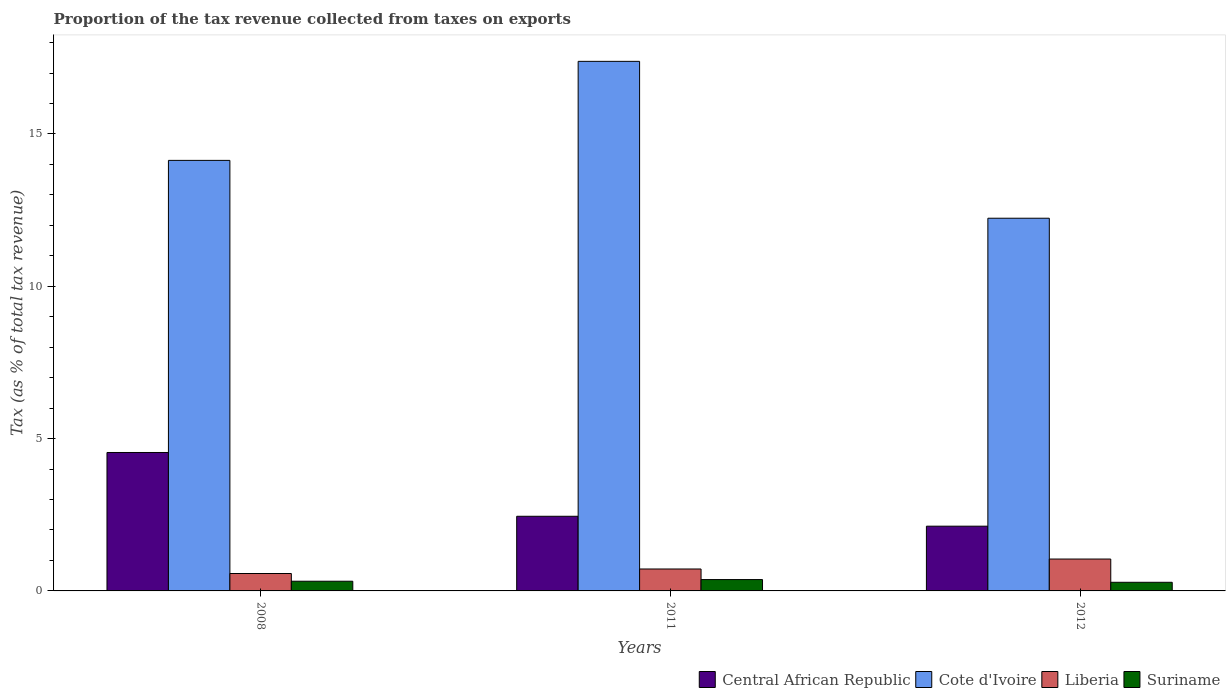How many different coloured bars are there?
Offer a very short reply. 4. How many groups of bars are there?
Your answer should be very brief. 3. How many bars are there on the 3rd tick from the right?
Offer a terse response. 4. What is the label of the 2nd group of bars from the left?
Your answer should be very brief. 2011. What is the proportion of the tax revenue collected in Central African Republic in 2012?
Offer a very short reply. 2.13. Across all years, what is the maximum proportion of the tax revenue collected in Cote d'Ivoire?
Offer a terse response. 17.38. Across all years, what is the minimum proportion of the tax revenue collected in Central African Republic?
Offer a terse response. 2.13. In which year was the proportion of the tax revenue collected in Central African Republic maximum?
Your answer should be compact. 2008. In which year was the proportion of the tax revenue collected in Central African Republic minimum?
Offer a very short reply. 2012. What is the total proportion of the tax revenue collected in Suriname in the graph?
Keep it short and to the point. 0.97. What is the difference between the proportion of the tax revenue collected in Central African Republic in 2011 and that in 2012?
Offer a terse response. 0.33. What is the difference between the proportion of the tax revenue collected in Suriname in 2008 and the proportion of the tax revenue collected in Liberia in 2012?
Ensure brevity in your answer.  -0.73. What is the average proportion of the tax revenue collected in Suriname per year?
Offer a very short reply. 0.32. In the year 2011, what is the difference between the proportion of the tax revenue collected in Liberia and proportion of the tax revenue collected in Central African Republic?
Offer a very short reply. -1.73. In how many years, is the proportion of the tax revenue collected in Liberia greater than 12 %?
Your answer should be very brief. 0. What is the ratio of the proportion of the tax revenue collected in Cote d'Ivoire in 2008 to that in 2011?
Keep it short and to the point. 0.81. Is the difference between the proportion of the tax revenue collected in Liberia in 2011 and 2012 greater than the difference between the proportion of the tax revenue collected in Central African Republic in 2011 and 2012?
Your response must be concise. No. What is the difference between the highest and the second highest proportion of the tax revenue collected in Central African Republic?
Give a very brief answer. 2.09. What is the difference between the highest and the lowest proportion of the tax revenue collected in Cote d'Ivoire?
Your answer should be compact. 5.15. In how many years, is the proportion of the tax revenue collected in Suriname greater than the average proportion of the tax revenue collected in Suriname taken over all years?
Make the answer very short. 1. Is it the case that in every year, the sum of the proportion of the tax revenue collected in Cote d'Ivoire and proportion of the tax revenue collected in Suriname is greater than the sum of proportion of the tax revenue collected in Central African Republic and proportion of the tax revenue collected in Liberia?
Your answer should be compact. Yes. What does the 3rd bar from the left in 2011 represents?
Provide a short and direct response. Liberia. What does the 1st bar from the right in 2011 represents?
Your answer should be compact. Suriname. Is it the case that in every year, the sum of the proportion of the tax revenue collected in Suriname and proportion of the tax revenue collected in Central African Republic is greater than the proportion of the tax revenue collected in Cote d'Ivoire?
Provide a succinct answer. No. How many bars are there?
Keep it short and to the point. 12. Where does the legend appear in the graph?
Provide a short and direct response. Bottom right. How many legend labels are there?
Your response must be concise. 4. What is the title of the graph?
Provide a short and direct response. Proportion of the tax revenue collected from taxes on exports. Does "Gabon" appear as one of the legend labels in the graph?
Your answer should be compact. No. What is the label or title of the Y-axis?
Ensure brevity in your answer.  Tax (as % of total tax revenue). What is the Tax (as % of total tax revenue) in Central African Republic in 2008?
Provide a short and direct response. 4.54. What is the Tax (as % of total tax revenue) of Cote d'Ivoire in 2008?
Make the answer very short. 14.13. What is the Tax (as % of total tax revenue) of Liberia in 2008?
Provide a succinct answer. 0.57. What is the Tax (as % of total tax revenue) of Suriname in 2008?
Give a very brief answer. 0.32. What is the Tax (as % of total tax revenue) in Central African Republic in 2011?
Your answer should be very brief. 2.45. What is the Tax (as % of total tax revenue) in Cote d'Ivoire in 2011?
Offer a terse response. 17.38. What is the Tax (as % of total tax revenue) in Liberia in 2011?
Your answer should be very brief. 0.72. What is the Tax (as % of total tax revenue) in Suriname in 2011?
Provide a succinct answer. 0.37. What is the Tax (as % of total tax revenue) of Central African Republic in 2012?
Your response must be concise. 2.13. What is the Tax (as % of total tax revenue) in Cote d'Ivoire in 2012?
Your response must be concise. 12.23. What is the Tax (as % of total tax revenue) of Liberia in 2012?
Provide a short and direct response. 1.05. What is the Tax (as % of total tax revenue) in Suriname in 2012?
Your response must be concise. 0.28. Across all years, what is the maximum Tax (as % of total tax revenue) of Central African Republic?
Make the answer very short. 4.54. Across all years, what is the maximum Tax (as % of total tax revenue) of Cote d'Ivoire?
Make the answer very short. 17.38. Across all years, what is the maximum Tax (as % of total tax revenue) of Liberia?
Offer a very short reply. 1.05. Across all years, what is the maximum Tax (as % of total tax revenue) in Suriname?
Your answer should be compact. 0.37. Across all years, what is the minimum Tax (as % of total tax revenue) in Central African Republic?
Your answer should be very brief. 2.13. Across all years, what is the minimum Tax (as % of total tax revenue) in Cote d'Ivoire?
Provide a short and direct response. 12.23. Across all years, what is the minimum Tax (as % of total tax revenue) in Liberia?
Give a very brief answer. 0.57. Across all years, what is the minimum Tax (as % of total tax revenue) in Suriname?
Keep it short and to the point. 0.28. What is the total Tax (as % of total tax revenue) of Central African Republic in the graph?
Give a very brief answer. 9.12. What is the total Tax (as % of total tax revenue) of Cote d'Ivoire in the graph?
Your answer should be very brief. 43.75. What is the total Tax (as % of total tax revenue) of Liberia in the graph?
Your answer should be very brief. 2.34. What is the total Tax (as % of total tax revenue) in Suriname in the graph?
Offer a terse response. 0.97. What is the difference between the Tax (as % of total tax revenue) of Central African Republic in 2008 and that in 2011?
Your answer should be very brief. 2.09. What is the difference between the Tax (as % of total tax revenue) in Cote d'Ivoire in 2008 and that in 2011?
Offer a very short reply. -3.25. What is the difference between the Tax (as % of total tax revenue) of Liberia in 2008 and that in 2011?
Offer a terse response. -0.15. What is the difference between the Tax (as % of total tax revenue) in Suriname in 2008 and that in 2011?
Make the answer very short. -0.05. What is the difference between the Tax (as % of total tax revenue) in Central African Republic in 2008 and that in 2012?
Keep it short and to the point. 2.42. What is the difference between the Tax (as % of total tax revenue) of Cote d'Ivoire in 2008 and that in 2012?
Provide a short and direct response. 1.9. What is the difference between the Tax (as % of total tax revenue) in Liberia in 2008 and that in 2012?
Keep it short and to the point. -0.47. What is the difference between the Tax (as % of total tax revenue) in Suriname in 2008 and that in 2012?
Provide a short and direct response. 0.04. What is the difference between the Tax (as % of total tax revenue) in Central African Republic in 2011 and that in 2012?
Offer a terse response. 0.33. What is the difference between the Tax (as % of total tax revenue) of Cote d'Ivoire in 2011 and that in 2012?
Your response must be concise. 5.15. What is the difference between the Tax (as % of total tax revenue) in Liberia in 2011 and that in 2012?
Your answer should be very brief. -0.33. What is the difference between the Tax (as % of total tax revenue) in Suriname in 2011 and that in 2012?
Keep it short and to the point. 0.09. What is the difference between the Tax (as % of total tax revenue) of Central African Republic in 2008 and the Tax (as % of total tax revenue) of Cote d'Ivoire in 2011?
Offer a terse response. -12.84. What is the difference between the Tax (as % of total tax revenue) of Central African Republic in 2008 and the Tax (as % of total tax revenue) of Liberia in 2011?
Offer a terse response. 3.82. What is the difference between the Tax (as % of total tax revenue) in Central African Republic in 2008 and the Tax (as % of total tax revenue) in Suriname in 2011?
Your response must be concise. 4.17. What is the difference between the Tax (as % of total tax revenue) of Cote d'Ivoire in 2008 and the Tax (as % of total tax revenue) of Liberia in 2011?
Ensure brevity in your answer.  13.41. What is the difference between the Tax (as % of total tax revenue) in Cote d'Ivoire in 2008 and the Tax (as % of total tax revenue) in Suriname in 2011?
Your answer should be very brief. 13.76. What is the difference between the Tax (as % of total tax revenue) in Liberia in 2008 and the Tax (as % of total tax revenue) in Suriname in 2011?
Provide a succinct answer. 0.2. What is the difference between the Tax (as % of total tax revenue) of Central African Republic in 2008 and the Tax (as % of total tax revenue) of Cote d'Ivoire in 2012?
Provide a short and direct response. -7.69. What is the difference between the Tax (as % of total tax revenue) in Central African Republic in 2008 and the Tax (as % of total tax revenue) in Liberia in 2012?
Ensure brevity in your answer.  3.5. What is the difference between the Tax (as % of total tax revenue) of Central African Republic in 2008 and the Tax (as % of total tax revenue) of Suriname in 2012?
Your answer should be compact. 4.26. What is the difference between the Tax (as % of total tax revenue) of Cote d'Ivoire in 2008 and the Tax (as % of total tax revenue) of Liberia in 2012?
Make the answer very short. 13.09. What is the difference between the Tax (as % of total tax revenue) in Cote d'Ivoire in 2008 and the Tax (as % of total tax revenue) in Suriname in 2012?
Ensure brevity in your answer.  13.85. What is the difference between the Tax (as % of total tax revenue) in Liberia in 2008 and the Tax (as % of total tax revenue) in Suriname in 2012?
Ensure brevity in your answer.  0.29. What is the difference between the Tax (as % of total tax revenue) in Central African Republic in 2011 and the Tax (as % of total tax revenue) in Cote d'Ivoire in 2012?
Provide a short and direct response. -9.78. What is the difference between the Tax (as % of total tax revenue) of Central African Republic in 2011 and the Tax (as % of total tax revenue) of Liberia in 2012?
Your answer should be very brief. 1.4. What is the difference between the Tax (as % of total tax revenue) in Central African Republic in 2011 and the Tax (as % of total tax revenue) in Suriname in 2012?
Offer a very short reply. 2.17. What is the difference between the Tax (as % of total tax revenue) in Cote d'Ivoire in 2011 and the Tax (as % of total tax revenue) in Liberia in 2012?
Ensure brevity in your answer.  16.34. What is the difference between the Tax (as % of total tax revenue) in Cote d'Ivoire in 2011 and the Tax (as % of total tax revenue) in Suriname in 2012?
Provide a short and direct response. 17.1. What is the difference between the Tax (as % of total tax revenue) in Liberia in 2011 and the Tax (as % of total tax revenue) in Suriname in 2012?
Your answer should be compact. 0.44. What is the average Tax (as % of total tax revenue) of Central African Republic per year?
Offer a very short reply. 3.04. What is the average Tax (as % of total tax revenue) of Cote d'Ivoire per year?
Your response must be concise. 14.58. What is the average Tax (as % of total tax revenue) of Liberia per year?
Keep it short and to the point. 0.78. What is the average Tax (as % of total tax revenue) of Suriname per year?
Your answer should be compact. 0.32. In the year 2008, what is the difference between the Tax (as % of total tax revenue) in Central African Republic and Tax (as % of total tax revenue) in Cote d'Ivoire?
Offer a terse response. -9.59. In the year 2008, what is the difference between the Tax (as % of total tax revenue) in Central African Republic and Tax (as % of total tax revenue) in Liberia?
Your answer should be compact. 3.97. In the year 2008, what is the difference between the Tax (as % of total tax revenue) of Central African Republic and Tax (as % of total tax revenue) of Suriname?
Your response must be concise. 4.23. In the year 2008, what is the difference between the Tax (as % of total tax revenue) of Cote d'Ivoire and Tax (as % of total tax revenue) of Liberia?
Keep it short and to the point. 13.56. In the year 2008, what is the difference between the Tax (as % of total tax revenue) of Cote d'Ivoire and Tax (as % of total tax revenue) of Suriname?
Make the answer very short. 13.82. In the year 2008, what is the difference between the Tax (as % of total tax revenue) of Liberia and Tax (as % of total tax revenue) of Suriname?
Your answer should be very brief. 0.25. In the year 2011, what is the difference between the Tax (as % of total tax revenue) in Central African Republic and Tax (as % of total tax revenue) in Cote d'Ivoire?
Your answer should be very brief. -14.93. In the year 2011, what is the difference between the Tax (as % of total tax revenue) in Central African Republic and Tax (as % of total tax revenue) in Liberia?
Make the answer very short. 1.73. In the year 2011, what is the difference between the Tax (as % of total tax revenue) of Central African Republic and Tax (as % of total tax revenue) of Suriname?
Ensure brevity in your answer.  2.08. In the year 2011, what is the difference between the Tax (as % of total tax revenue) of Cote d'Ivoire and Tax (as % of total tax revenue) of Liberia?
Make the answer very short. 16.66. In the year 2011, what is the difference between the Tax (as % of total tax revenue) in Cote d'Ivoire and Tax (as % of total tax revenue) in Suriname?
Provide a succinct answer. 17.01. In the year 2011, what is the difference between the Tax (as % of total tax revenue) in Liberia and Tax (as % of total tax revenue) in Suriname?
Give a very brief answer. 0.35. In the year 2012, what is the difference between the Tax (as % of total tax revenue) in Central African Republic and Tax (as % of total tax revenue) in Cote d'Ivoire?
Your response must be concise. -10.11. In the year 2012, what is the difference between the Tax (as % of total tax revenue) of Central African Republic and Tax (as % of total tax revenue) of Liberia?
Provide a short and direct response. 1.08. In the year 2012, what is the difference between the Tax (as % of total tax revenue) in Central African Republic and Tax (as % of total tax revenue) in Suriname?
Your response must be concise. 1.84. In the year 2012, what is the difference between the Tax (as % of total tax revenue) of Cote d'Ivoire and Tax (as % of total tax revenue) of Liberia?
Your response must be concise. 11.19. In the year 2012, what is the difference between the Tax (as % of total tax revenue) of Cote d'Ivoire and Tax (as % of total tax revenue) of Suriname?
Make the answer very short. 11.95. In the year 2012, what is the difference between the Tax (as % of total tax revenue) of Liberia and Tax (as % of total tax revenue) of Suriname?
Provide a short and direct response. 0.76. What is the ratio of the Tax (as % of total tax revenue) in Central African Republic in 2008 to that in 2011?
Your response must be concise. 1.85. What is the ratio of the Tax (as % of total tax revenue) in Cote d'Ivoire in 2008 to that in 2011?
Offer a terse response. 0.81. What is the ratio of the Tax (as % of total tax revenue) of Liberia in 2008 to that in 2011?
Your answer should be very brief. 0.79. What is the ratio of the Tax (as % of total tax revenue) of Suriname in 2008 to that in 2011?
Ensure brevity in your answer.  0.85. What is the ratio of the Tax (as % of total tax revenue) of Central African Republic in 2008 to that in 2012?
Provide a short and direct response. 2.14. What is the ratio of the Tax (as % of total tax revenue) of Cote d'Ivoire in 2008 to that in 2012?
Offer a terse response. 1.16. What is the ratio of the Tax (as % of total tax revenue) of Liberia in 2008 to that in 2012?
Provide a succinct answer. 0.55. What is the ratio of the Tax (as % of total tax revenue) of Suriname in 2008 to that in 2012?
Make the answer very short. 1.12. What is the ratio of the Tax (as % of total tax revenue) of Central African Republic in 2011 to that in 2012?
Keep it short and to the point. 1.15. What is the ratio of the Tax (as % of total tax revenue) of Cote d'Ivoire in 2011 to that in 2012?
Your answer should be compact. 1.42. What is the ratio of the Tax (as % of total tax revenue) of Liberia in 2011 to that in 2012?
Your response must be concise. 0.69. What is the ratio of the Tax (as % of total tax revenue) in Suriname in 2011 to that in 2012?
Give a very brief answer. 1.31. What is the difference between the highest and the second highest Tax (as % of total tax revenue) of Central African Republic?
Give a very brief answer. 2.09. What is the difference between the highest and the second highest Tax (as % of total tax revenue) in Cote d'Ivoire?
Your answer should be compact. 3.25. What is the difference between the highest and the second highest Tax (as % of total tax revenue) of Liberia?
Your answer should be very brief. 0.33. What is the difference between the highest and the second highest Tax (as % of total tax revenue) of Suriname?
Provide a succinct answer. 0.05. What is the difference between the highest and the lowest Tax (as % of total tax revenue) of Central African Republic?
Ensure brevity in your answer.  2.42. What is the difference between the highest and the lowest Tax (as % of total tax revenue) of Cote d'Ivoire?
Ensure brevity in your answer.  5.15. What is the difference between the highest and the lowest Tax (as % of total tax revenue) in Liberia?
Provide a succinct answer. 0.47. What is the difference between the highest and the lowest Tax (as % of total tax revenue) in Suriname?
Give a very brief answer. 0.09. 